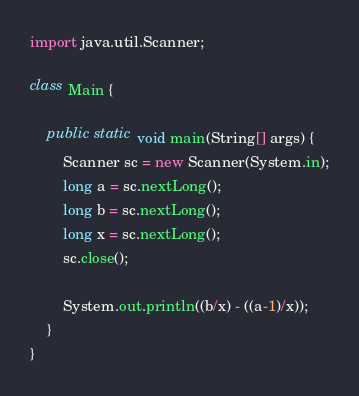Convert code to text. <code><loc_0><loc_0><loc_500><loc_500><_Java_>import java.util.Scanner;
    
class Main {
 
    public static void main(String[] args) {
        Scanner sc = new Scanner(System.in);
        long a = sc.nextLong();
        long b = sc.nextLong();
        long x = sc.nextLong();
        sc.close();

        System.out.println((b/x) - ((a-1)/x));
    }
}
</code> 